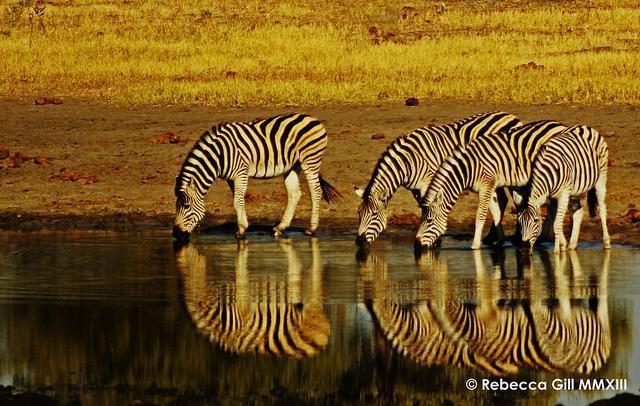How many zebras are there?
Give a very brief answer. 4. How many train track junctions can be seen?
Give a very brief answer. 0. 